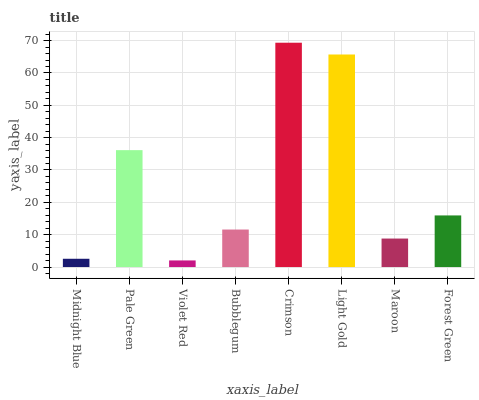Is Violet Red the minimum?
Answer yes or no. Yes. Is Crimson the maximum?
Answer yes or no. Yes. Is Pale Green the minimum?
Answer yes or no. No. Is Pale Green the maximum?
Answer yes or no. No. Is Pale Green greater than Midnight Blue?
Answer yes or no. Yes. Is Midnight Blue less than Pale Green?
Answer yes or no. Yes. Is Midnight Blue greater than Pale Green?
Answer yes or no. No. Is Pale Green less than Midnight Blue?
Answer yes or no. No. Is Forest Green the high median?
Answer yes or no. Yes. Is Bubblegum the low median?
Answer yes or no. Yes. Is Maroon the high median?
Answer yes or no. No. Is Forest Green the low median?
Answer yes or no. No. 